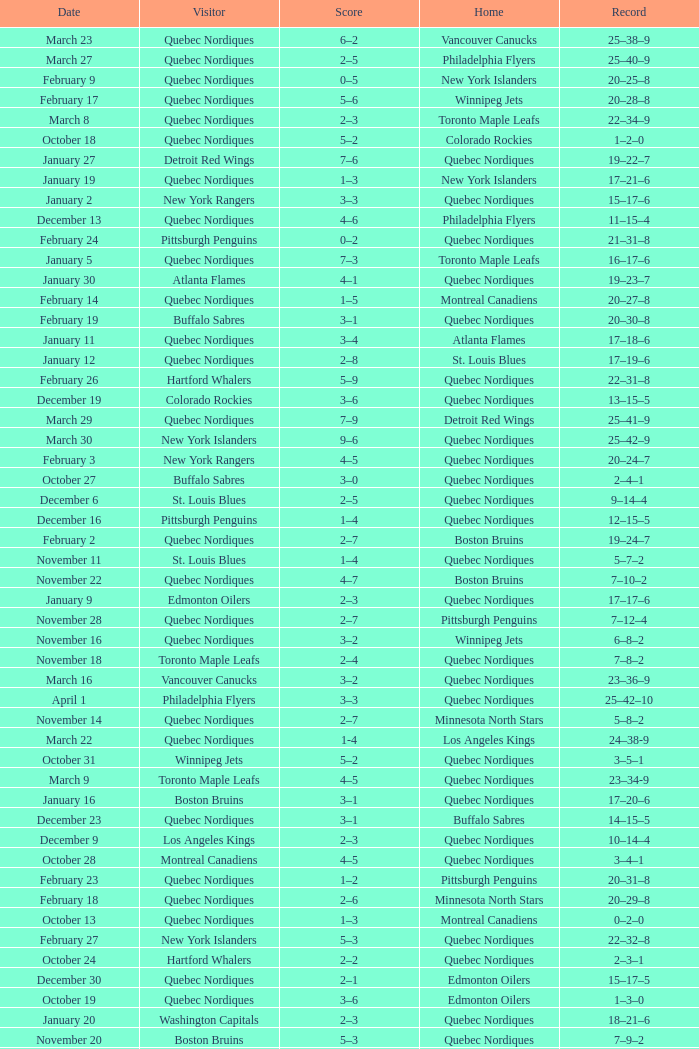Which Home has a Record of 16–17–6? Toronto Maple Leafs. 